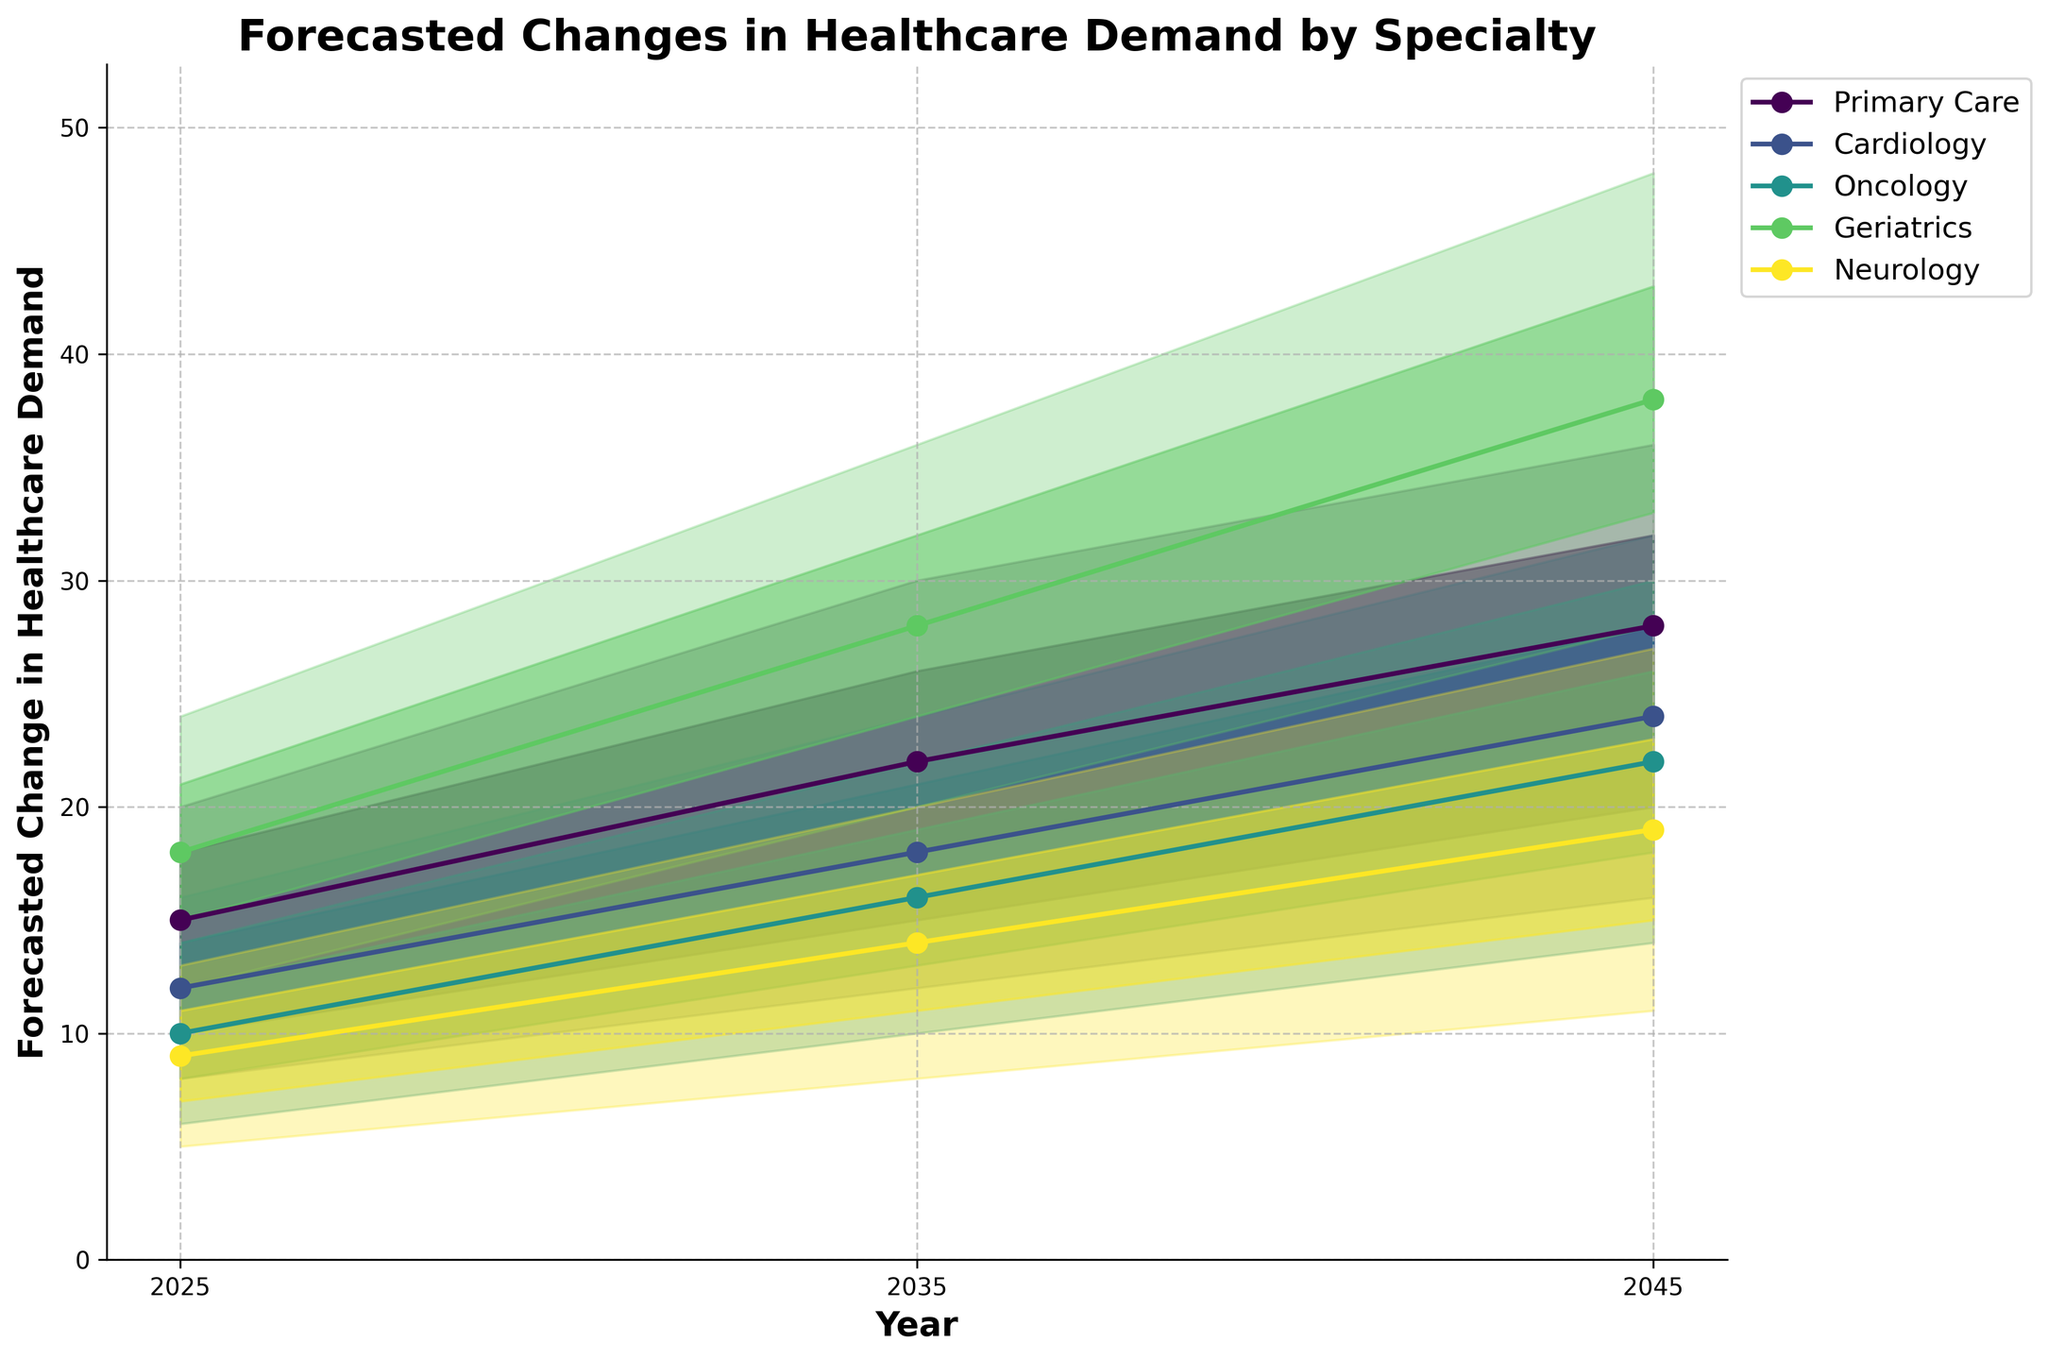What specialties are forecasted in the chart? By observing the labels and legend in the chart, we can identify the specialties listed. The specialties include Primary Care, Cardiology, Oncology, Geriatrics, and Neurology.
Answer: Primary Care, Cardiology, Oncology, Geriatrics, Neurology What is the title of the chart? The title of the chart is present at the top of the figure and it reads: 'Forecasted Changes in Healthcare Demand by Specialty'.
Answer: Forecasted Changes in Healthcare Demand by Specialty Which specialty shows the highest forecasted demand in 2045 according to the mid estimate? To determine this, observe the mid estimate line for each specialty in 2045. The Geriatrics specialty has the highest mid estimate value.
Answer: Geriatrics By how much is the demand for Primary Care predicted to increase from 2025 to 2045, according to the mid estimate? Look at the mid estimate values for Primary Care in 2025 and 2045, which are 15 and 28, respectively. The increase is 28 - 15 = 13.
Answer: 13 What is the range of forecasted demand values for Oncology in 2035? Observe the Oncology specialty's shaded area for 2035 for the range. The low estimate is 10 and the high estimate is 22, making the range 10 to 22.
Answer: 10 to 22 Comparing the high estimates, which specialty shows the smallest increase in demand from 2025 to 2045? Calculate the increase for each specialty using the high estimates in 2025 and 2045. The smallest increase is for Neurology, which goes from 13 to 27 (an increase of 14).
Answer: Neurology Which specialty is consistently showing a higher forecasted demand than Oncology across all years? By comparing the mid estimate lines, Geriatrics consistently shows a higher forecasted demand than Oncology in all the years provided (2025, 2035, 2045).
Answer: Geriatrics What is the expected average demand for Cardiology in 2045 based on the mid estimate? The mid estimate for Cardiology in 2045 is directly shown.
Answer: 24 What pattern do you observe in the forecasted demand for Geriatrics from 2025 to 2045? Notice the trend in the mid estimate for Geriatrics over the years. It starts at 18 in 2025, increases to 28 in 2035, and again increases to 38 in 2045. This shows a consistent increase.
Answer: Consistent increase 